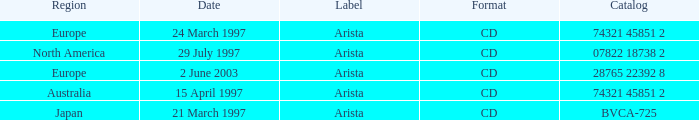What's the Date with the Region of Europe and has a Catalog of 28765 22392 8? 2 June 2003. 